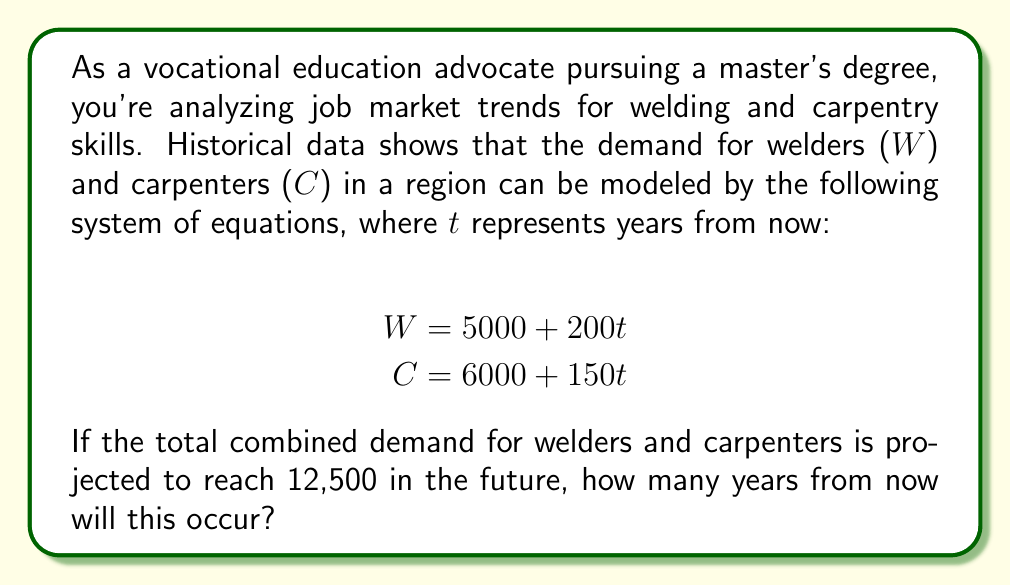Can you solve this math problem? To solve this problem, we'll follow these steps:

1) We know that the total combined demand will be 12,500. This means we can set up an equation:

   $W + C = 12500$

2) We can substitute the given equations for $W$ and $C$:

   $(5000 + 200t) + (6000 + 150t) = 12500$

3) Let's simplify the left side of the equation:

   $11000 + 350t = 12500$

4) Now we can solve for $t$:
   
   $350t = 12500 - 11000$
   $350t = 1500$

5) Divide both sides by 350:

   $t = \frac{1500}{350} = \frac{150}{35} = \frac{30}{7} \approx 4.29$

Therefore, it will take approximately 4.29 years for the combined demand to reach 12,500.
Answer: $\frac{30}{7}$ years (approximately 4.29 years) 